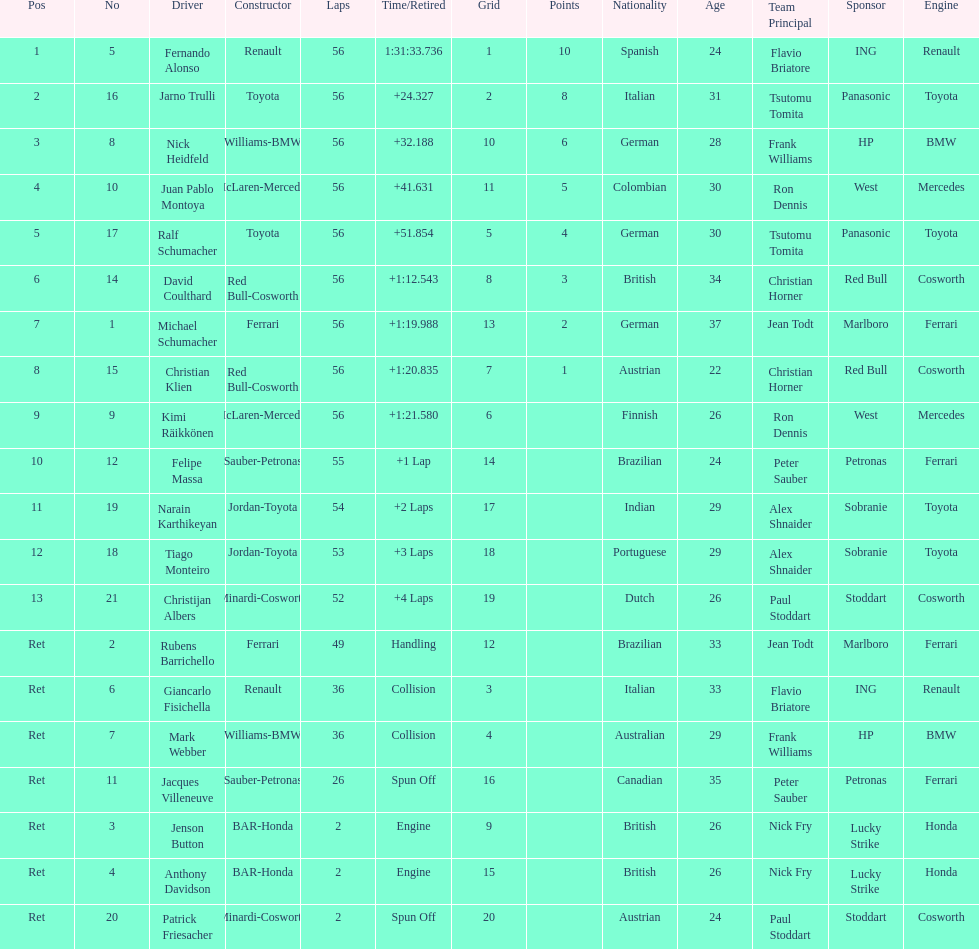How many drivers ended the race early because of engine problems? 2. 